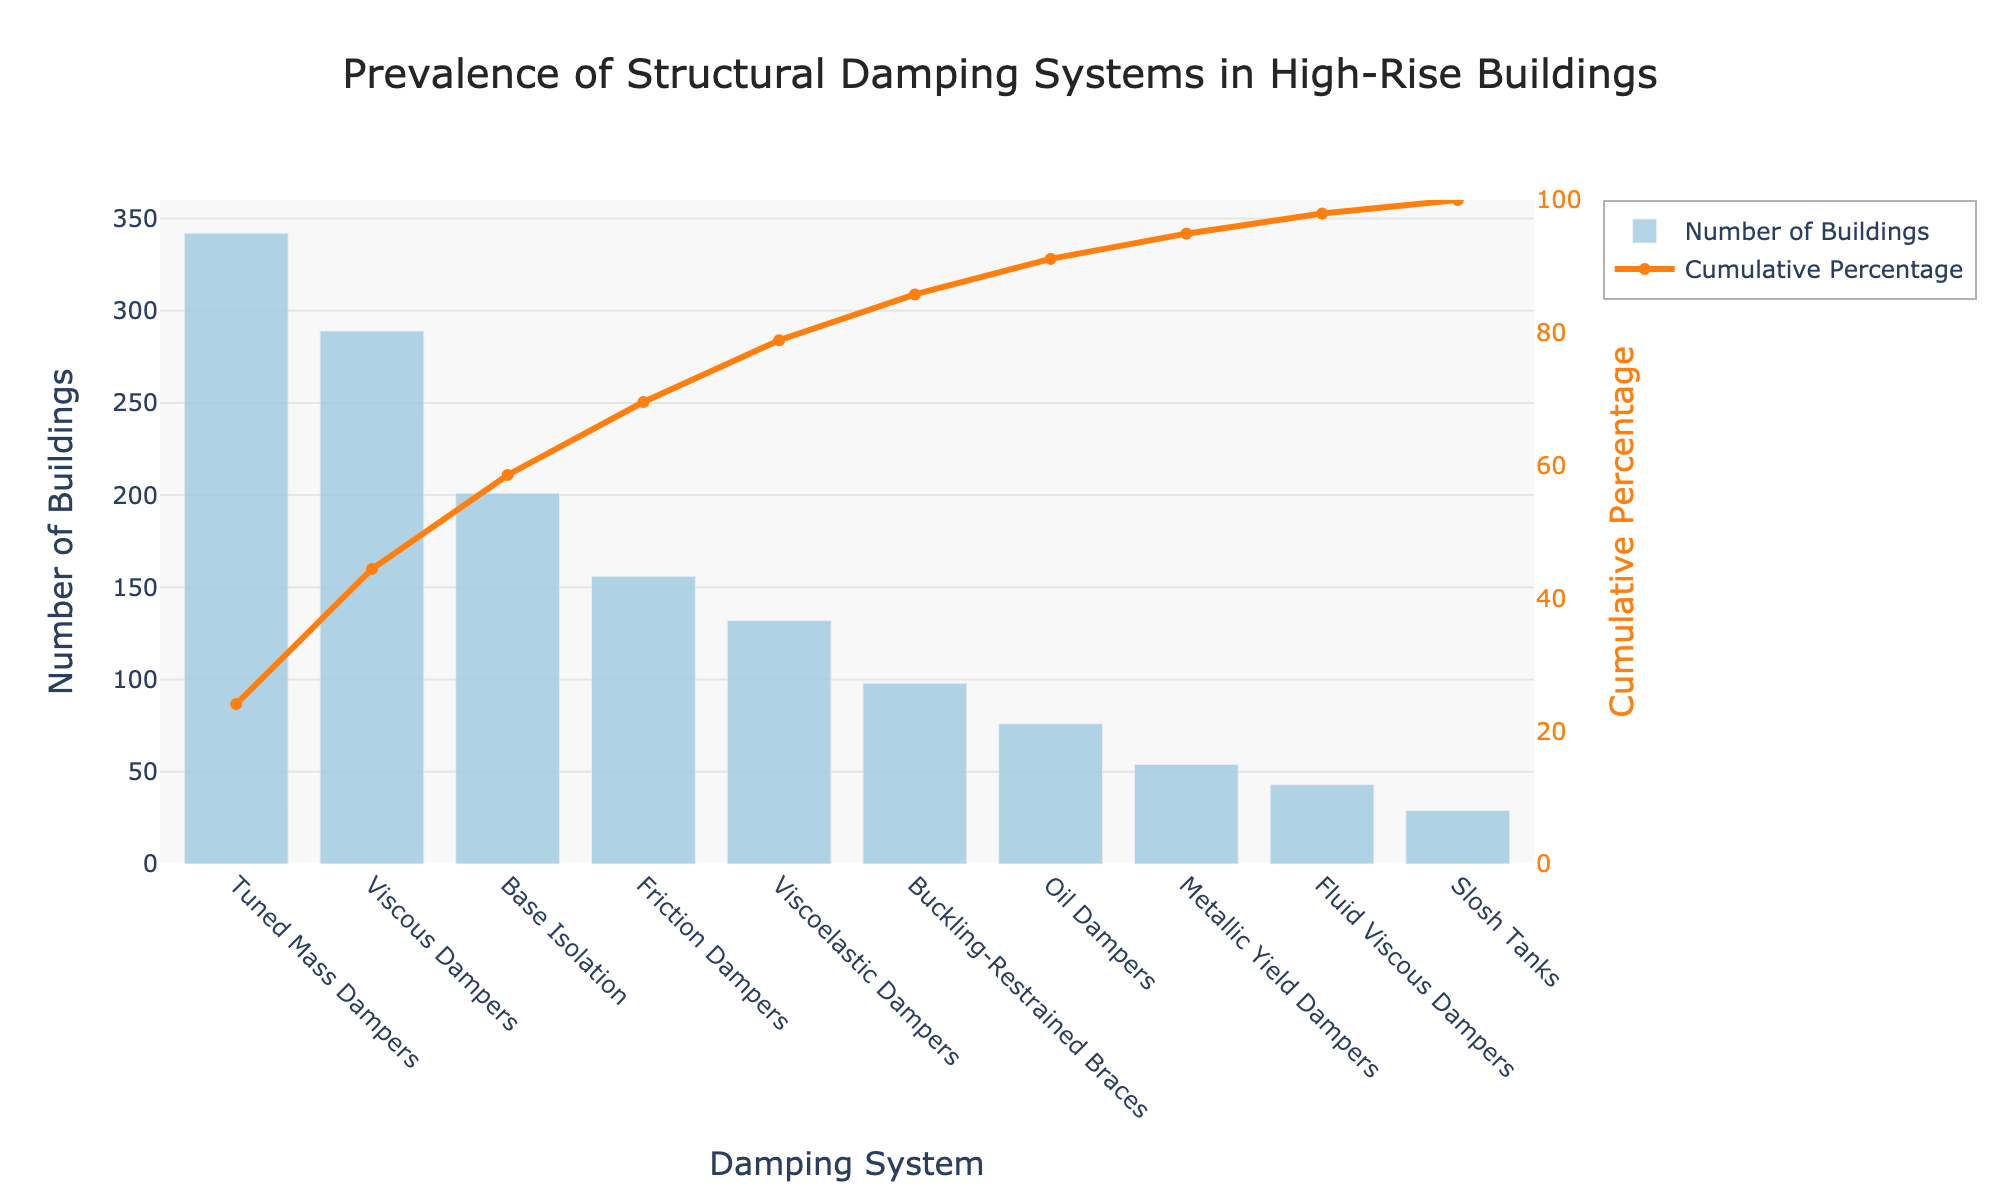what is the title of the Pareto chart? The title is located at the top center of the chart and reads "Prevalence of Structural Damping Systems in High-Rise Buildings".
Answer: Prevalence of Structural Damping Systems in High-Rise Buildings Which damping system is used in the highest number of buildings? The first bar on the left (highest bar) corresponds to the "Tuned Mass Dampers" category, with the highest value of 342 buildings.
Answer: Tuned Mass Dampers What is the cumulative percentage of buildings using the top three damping systems combined? Add the cumulative percentages of Tuned Mass Dampers, Viscous Dampers, and Base Isolation from the orange line indicating cumulative percentages. They add up to about 51%, 34%, and 20% respectively. It translates to the value just above 80%.
Answer: ~80% How many buildings use oil dampers? Locate the bar corresponding to "Oil Dampers" on the x-axis; it has a height indicating 76 buildings.
Answer: 76 Which damping systems have a cumulative percentage exceeding 60%? Follow the cumulative percentage line and see where it cuts off at 60%. "Tuned Mass Dampers", "Viscous Dampers", and "Base Isolation" will be the systems.
Answer: Tuned Mass Dampers, Viscous Dampers, Base Isolation Which damping system contributes the least to the overall number of buildings? The shortest bar on the chart represents "Slosh Tanks" with only 29 buildings.
Answer: Slosh Tanks What is the difference in the number of buildings using tuned mass dampers and viscous dampers? Subtract the number of buildings for Viscous Dampers from Tuned Mass Dampers (342 - 289).
Answer: 53 What percentage of buildings use viscoelastic dampers and friction dampers combined? Add the number of buildings for both categories (132 + 156) and compute the percentage of the total number of buildings (sum of all categories, which is 1420). The result is ((132 + 156) / 1420) * 100 = 20.28%.
Answer: ~20.28% How many damping systems are used in fewer than 100 buildings each? Count the categories with less than 100 buildings: "Buckling-Restrained Braces", "Oil Dampers", "Metallic Yield Dampers", "Fluid Viscous Dampers", "Slosh Tanks". There are five systems.
Answer: 5 Which damping systems hold around 90% of cumulative percentage? Trace the cumulative percentage line to check where it is around 90% and consider the damping systems contributing to it. They are Tuned Mass Dampers, Viscous Dampers, Base Isolation, Friction Dampers, and Viscoelastic Dampers.
Answer: Tuned Mass Dampers, Viscous Dampers, Base Isolation, Friction Dampers, Viscoelastic Dampers 